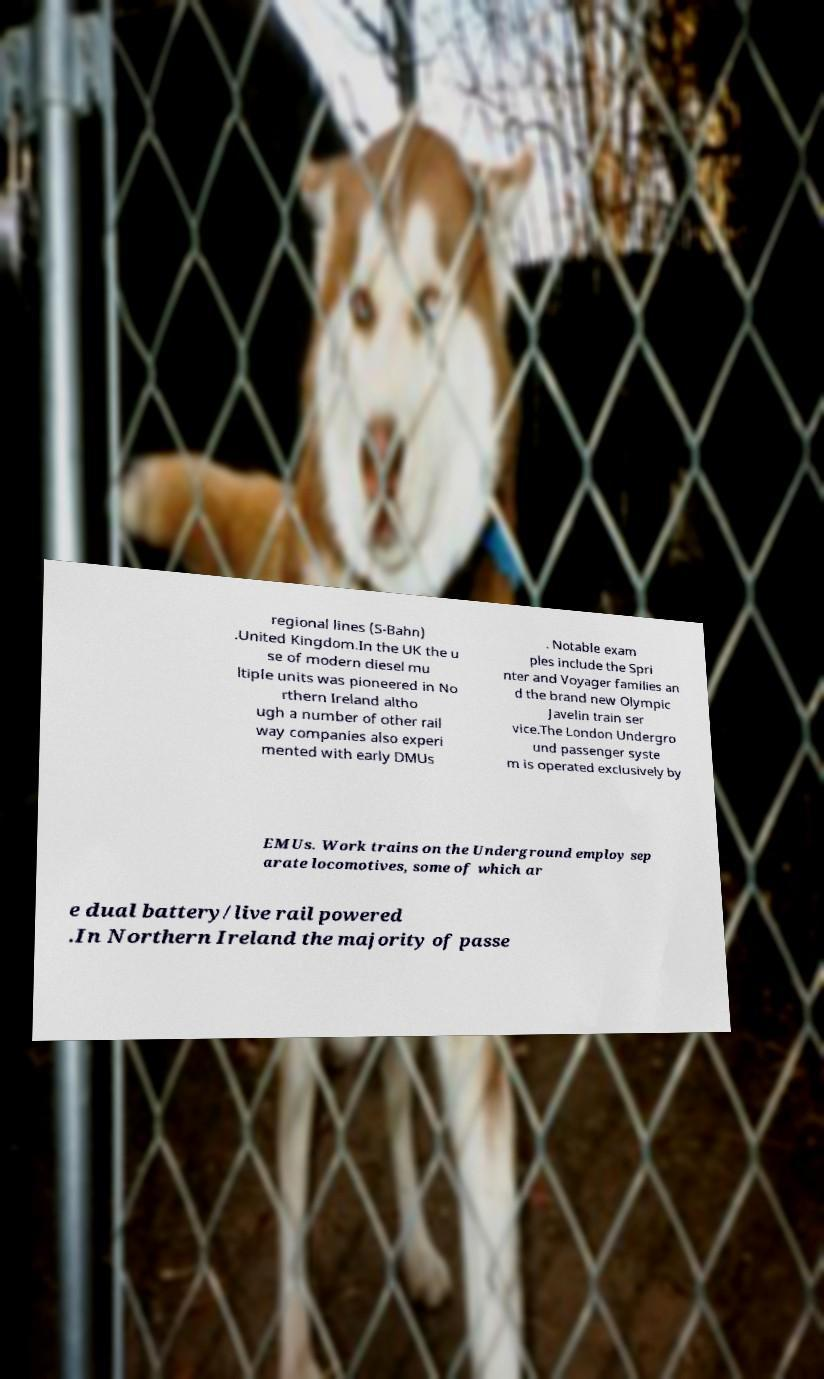For documentation purposes, I need the text within this image transcribed. Could you provide that? regional lines (S-Bahn) .United Kingdom.In the UK the u se of modern diesel mu ltiple units was pioneered in No rthern Ireland altho ugh a number of other rail way companies also experi mented with early DMUs . Notable exam ples include the Spri nter and Voyager families an d the brand new Olympic Javelin train ser vice.The London Undergro und passenger syste m is operated exclusively by EMUs. Work trains on the Underground employ sep arate locomotives, some of which ar e dual battery/live rail powered .In Northern Ireland the majority of passe 